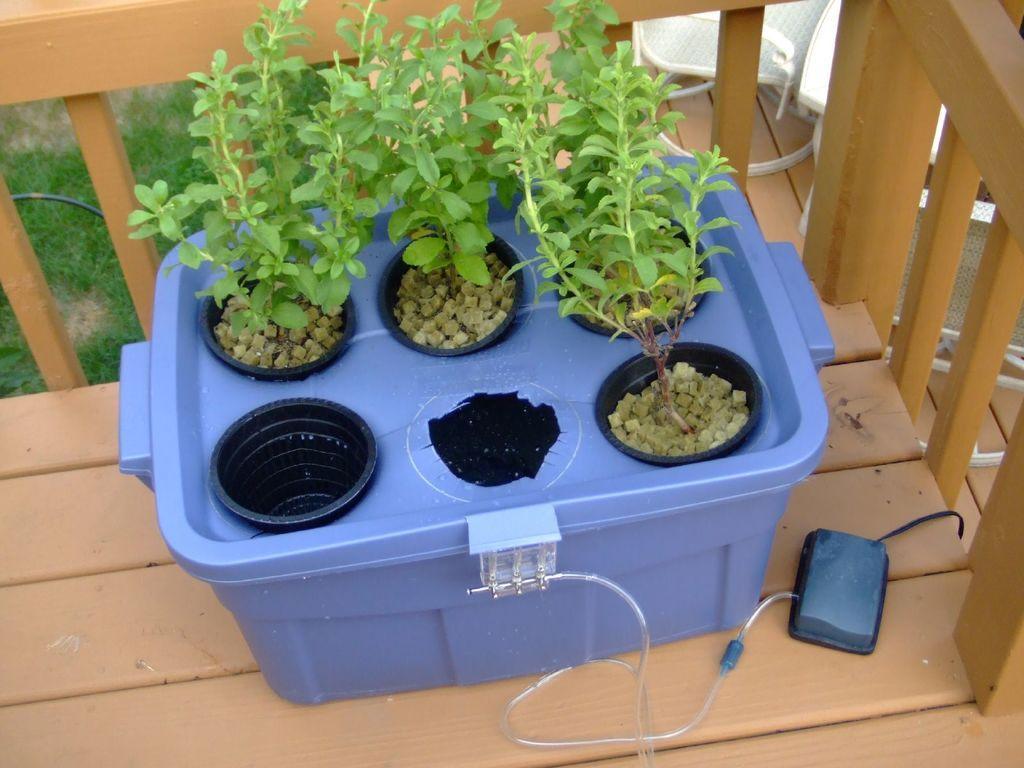Please provide a concise description of this image. In this image I can see few plants in green color and I can also see the basket in blue color and the basket is on the wooden surface. In the background I can see the grass in green color. 